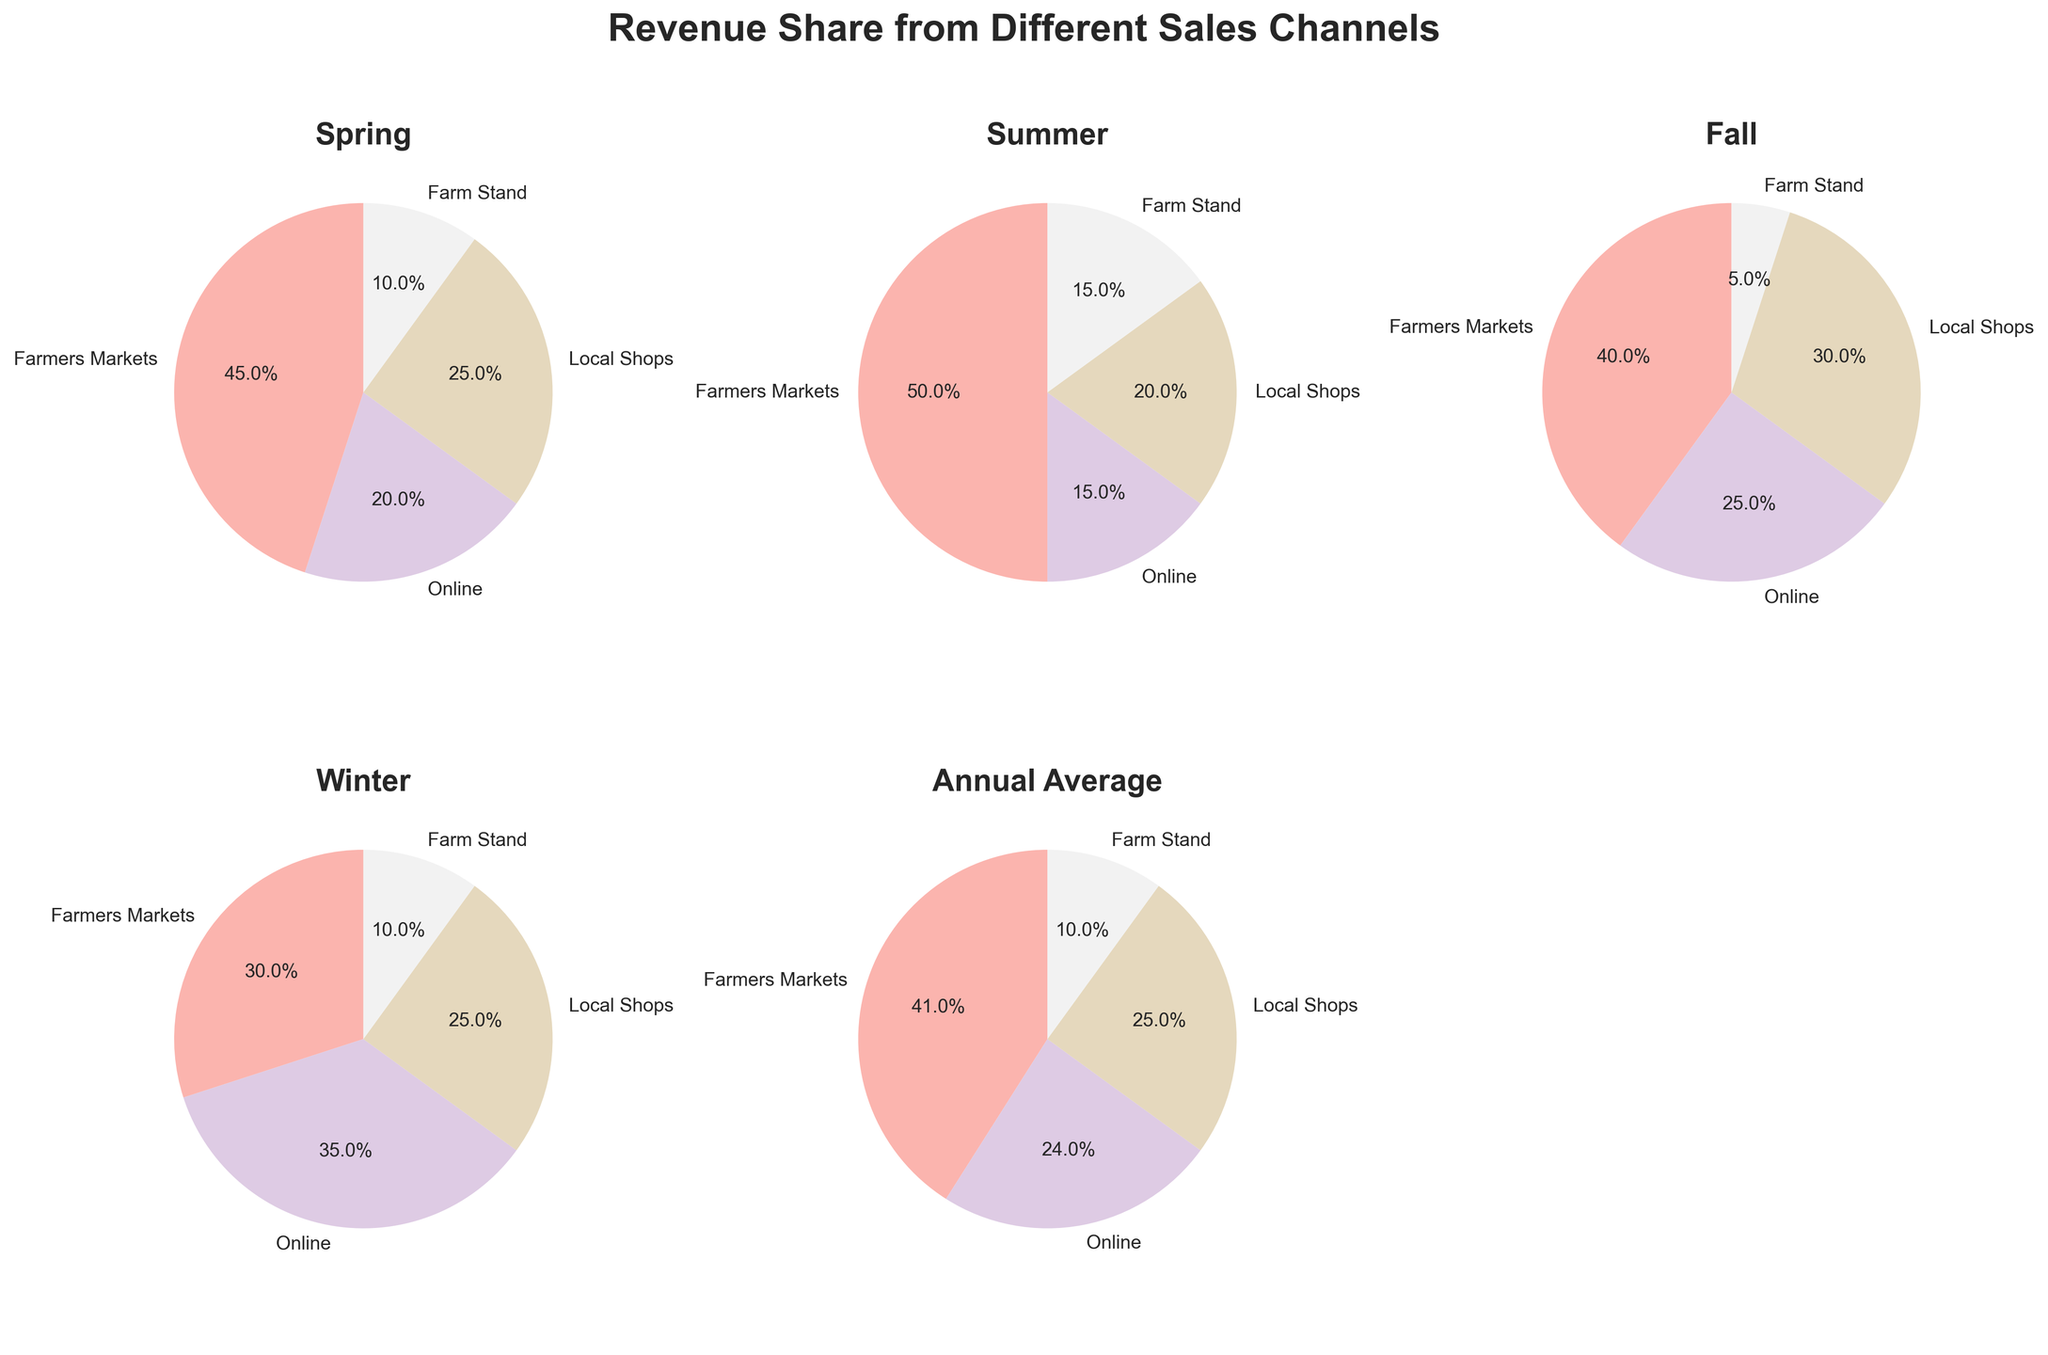Which season has the highest revenue share from Farmers Markets? To determine this, we need to look at each pie chart and identify the largest piece in terms of both percentage and the label for Farmers Markets. The largest slice corresponding to Farmers Markets is in the Summer with 50%.
Answer: Summer What is the smallest revenue share category in Fall? By inspecting the Fall pie chart, we can see the smallest slice is for Farm Stand, contributing only 5% of the revenue.
Answer: Farm Stand How does the revenue share from Online sales in Winter compare to Spring? By comparing the pie charts for Winter and Spring, we see that the Online sales share in Winter is 35% and in Spring it is 20%. 35% is greater than 20%.
Answer: Winter has more What's the difference in percentage between Local Shops and Farm Stand revenue shares in Annual Average? From the Annual Average pie chart, Local Shops have a 25% share and Farm Stand has a 10% share. The difference is 25% - 10% = 15%.
Answer: 15% Which season has the most evenly distributed revenue shares among all channels? Observing all the pie charts, the Winter season appears to have shares that are relatively similar: Farmers Markets 30%, Online 35%, Local Shops 25%, and Farm Stand 10%.
Answer: Winter What is the total percentage of revenue share from Local Shops across Spring and Fall? Looking at the charts, Local Shops have 25% in Spring and 30% in Fall. Summing these gives 25% + 30% = 55%.
Answer: 55% How does the Farm Stand revenue share in Summer compare visually to Winter? Visually, the slice corresponding to Farm Stand in Summer appears larger than in Winter. Summer has a 15% share while Winter has 10%.
Answer: Summer is larger Which sales channel has the most consistent share from season to season? Analyzing the pie charts, Farm Stand remains quite consistent with shares of 10%, 15%, 5%, and 10% across the seasons. Local Shops also show consistency but with a slightly larger fluctuation (25%-30% range).
Answer: Farm Stand 